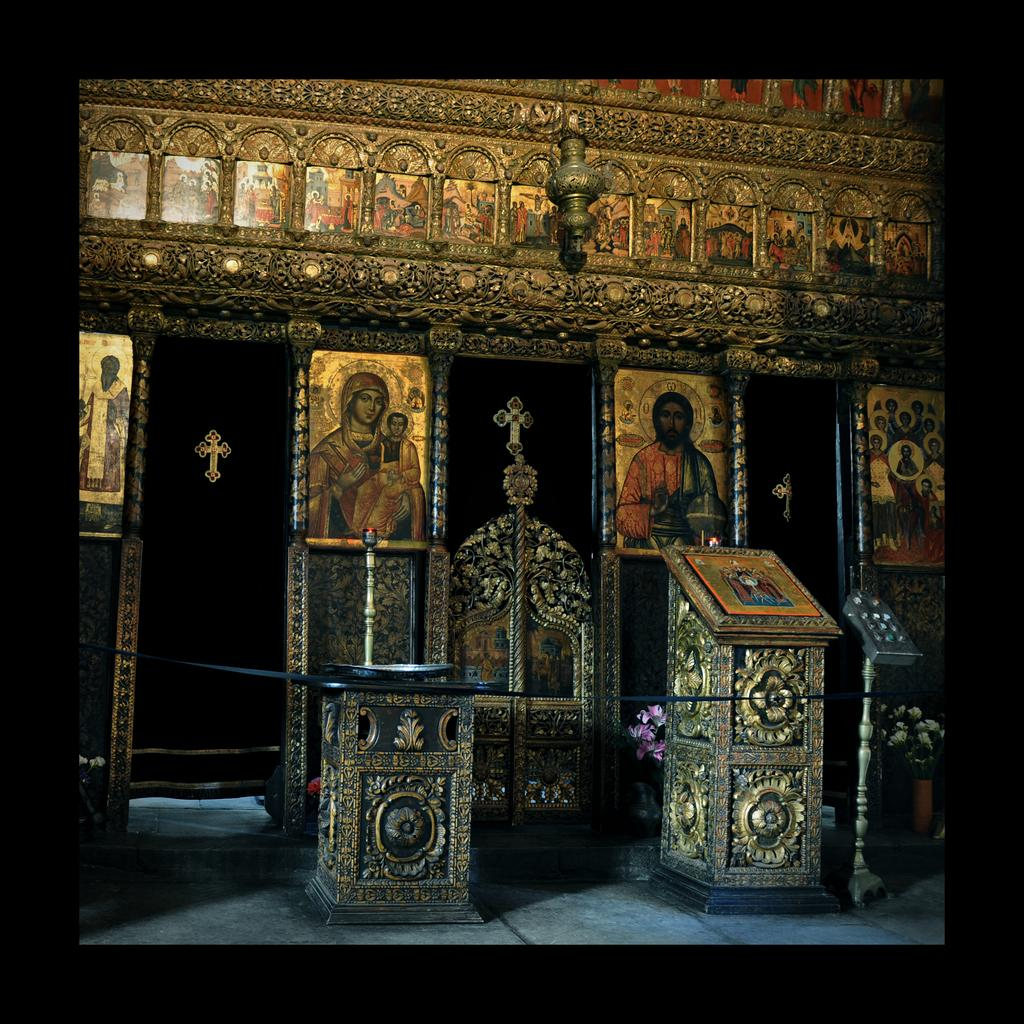What can be seen hanging on the wall in the image? There are photo frames on the wall. What structure is present in the image? There is a podium in the image. What is placed on a stand in the image? There are objects on a stand. Can you describe the object that is hung in the image? There is an object hung in the image, but the specific details are not mentioned in the facts. What is the color of the borders of the image? The borders of the image are black in color. What is the rate of ice melting in the image? There is no ice present in the image, so it is not possible to determine the rate of ice melting. What type of pot is used to cook the object hung in the image? There is no pot or cooking activity present in the image. 